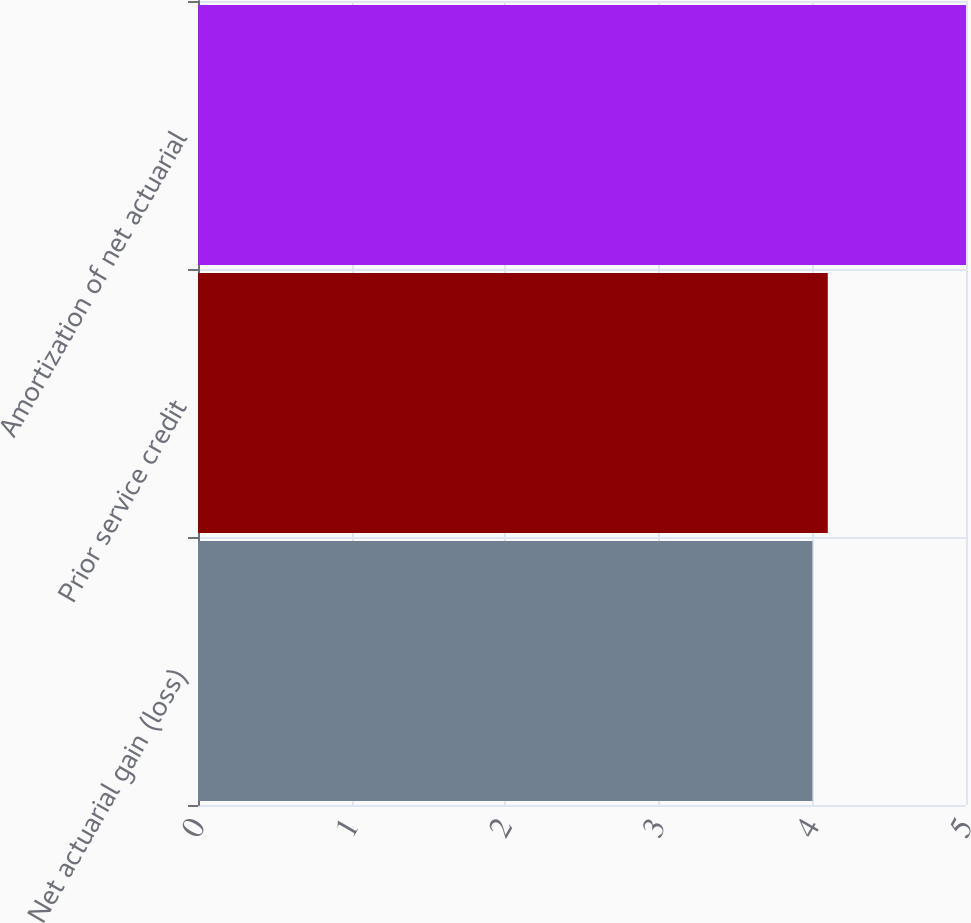Convert chart. <chart><loc_0><loc_0><loc_500><loc_500><bar_chart><fcel>Net actuarial gain (loss)<fcel>Prior service credit<fcel>Amortization of net actuarial<nl><fcel>4<fcel>4.1<fcel>5<nl></chart> 